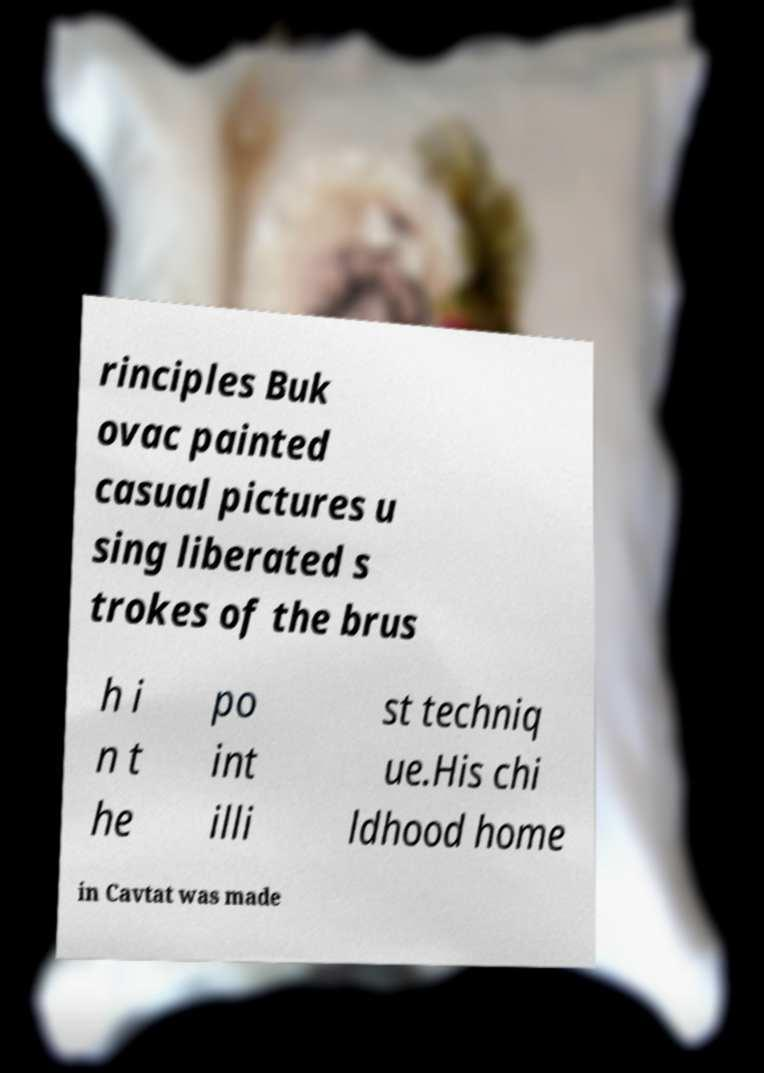Can you read and provide the text displayed in the image?This photo seems to have some interesting text. Can you extract and type it out for me? rinciples Buk ovac painted casual pictures u sing liberated s trokes of the brus h i n t he po int illi st techniq ue.His chi ldhood home in Cavtat was made 